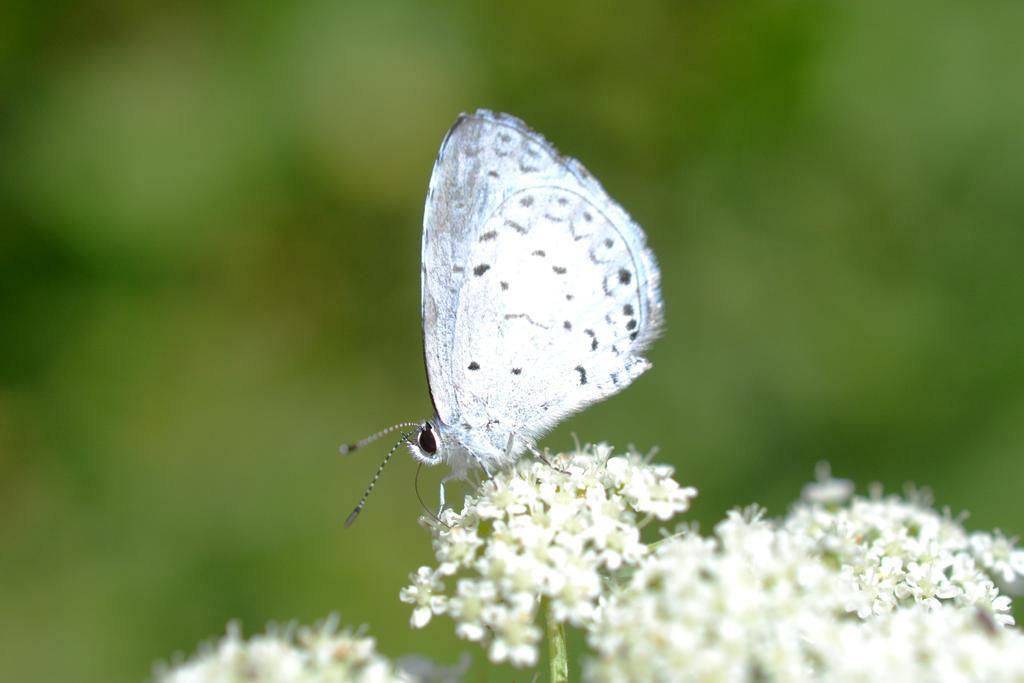Please provide a concise description of this image. There are white color flowers. On that there is a white butterfly. In the background it is green and blurred. 